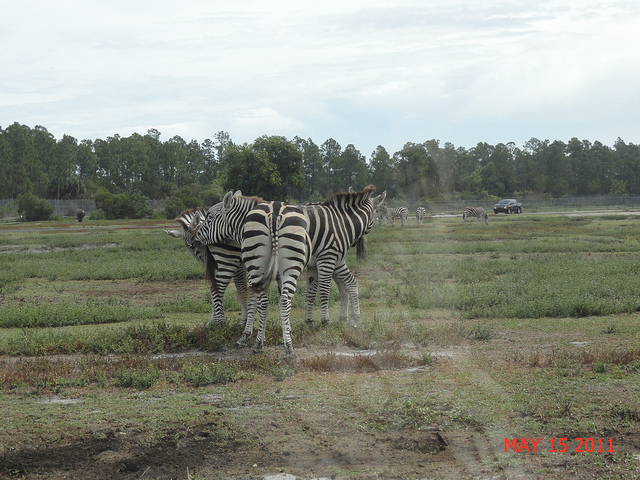Please identify all text content in this image. MAY 15 2011 